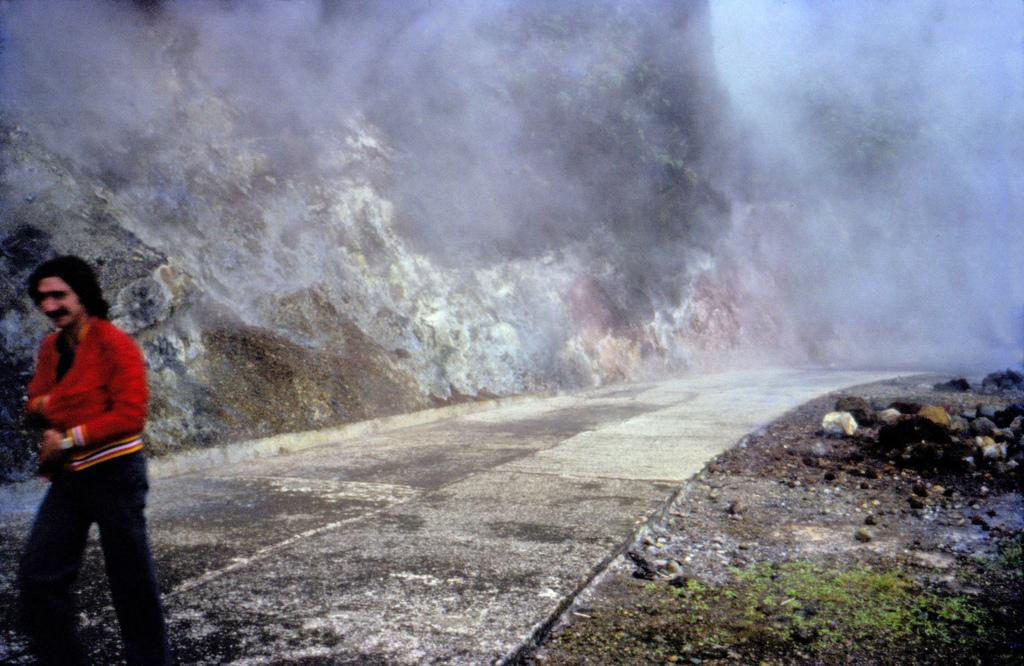What can be seen in the image? There is a person in the image. What is the person wearing? The person is wearing a red jacket. Where is the person standing? The person is standing on the road. What else can be seen on the road? There are stones visible in the image. What is visible in the background of the image? There are hills in the background of the image. What else can be seen in the image? There is smoke visible in the image. What type of trousers is the person wearing in the image? The provided facts do not mention the type of trousers the person is wearing, so we cannot answer this question definitively. --- Facts: 1. There is a car in the image. 2. The car is parked on the street. 3. There are trees visible in the image. 4. The car has a blue color. 5. There is a traffic light in the image. Absurd Topics: parrot, sand, dance Conversation: What can be seen in the image? There is a car in the image. Where is the car located? The car is parked on the street. What else can be seen in the image? There are trees visible in the image. What is the color of the car? The car has a blue color. What else can be seen in the image related to traffic? There is a traffic light in the image. Reasoning: Let's think step by step in order to produce the conversation. We start by identifying the main subject in the image, which is the car. Then, we expand the conversation to include details about the car's location, color, and other objects visible in the image. Each question is designed to elicit a specific detail about the image that is known from the provided facts. Absurd Question/Answer: Can you tell me how many parrots are sitting on the car in the image? There are no parrots visible in the image, so we cannot answer this question definitively. 